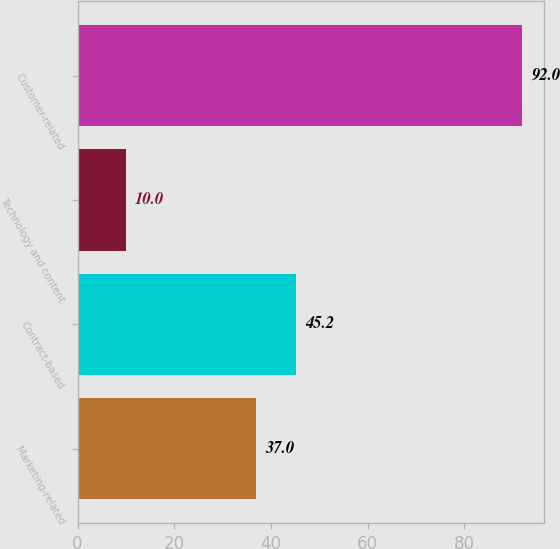Convert chart. <chart><loc_0><loc_0><loc_500><loc_500><bar_chart><fcel>Marketing-related<fcel>Contract-based<fcel>Technology and content<fcel>Customer-related<nl><fcel>37<fcel>45.2<fcel>10<fcel>92<nl></chart> 